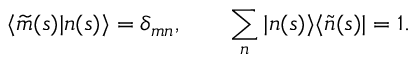<formula> <loc_0><loc_0><loc_500><loc_500>\langle \widetilde { m } ( s ) | n ( s ) \rangle = \delta _ { m n } , \quad \sum _ { n } | n ( s ) \rangle \langle \widetilde { n } ( s ) | = 1 .</formula> 